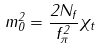Convert formula to latex. <formula><loc_0><loc_0><loc_500><loc_500>m _ { 0 } ^ { 2 } = \frac { 2 N _ { f } } { f _ { \pi } ^ { 2 } } \chi _ { t }</formula> 